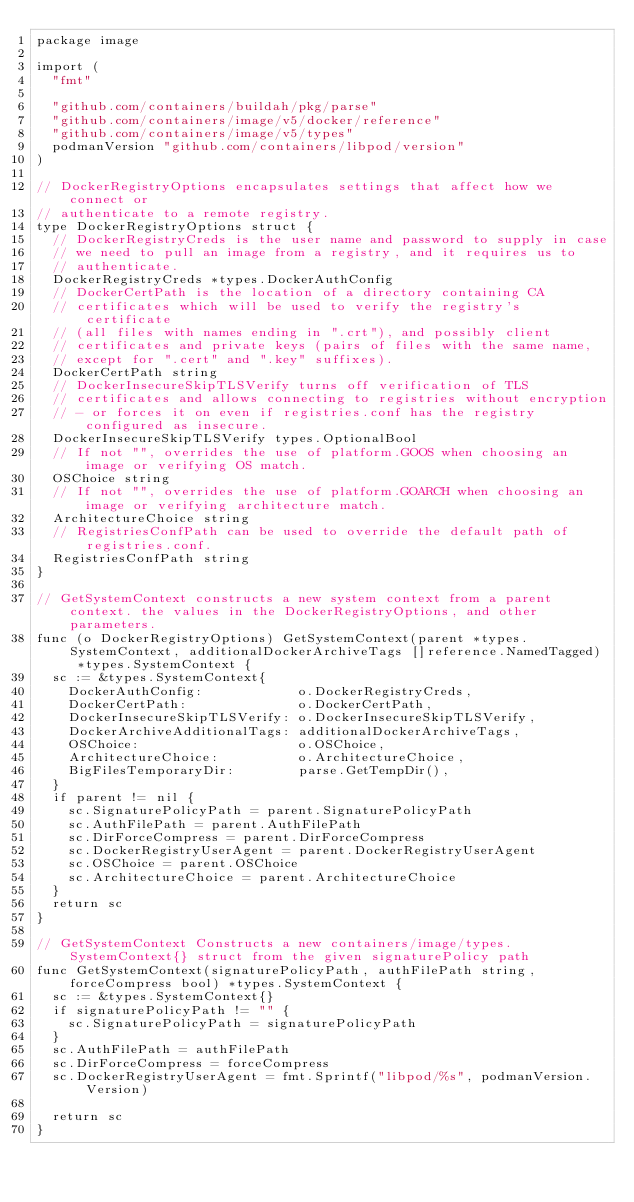Convert code to text. <code><loc_0><loc_0><loc_500><loc_500><_Go_>package image

import (
	"fmt"

	"github.com/containers/buildah/pkg/parse"
	"github.com/containers/image/v5/docker/reference"
	"github.com/containers/image/v5/types"
	podmanVersion "github.com/containers/libpod/version"
)

// DockerRegistryOptions encapsulates settings that affect how we connect or
// authenticate to a remote registry.
type DockerRegistryOptions struct {
	// DockerRegistryCreds is the user name and password to supply in case
	// we need to pull an image from a registry, and it requires us to
	// authenticate.
	DockerRegistryCreds *types.DockerAuthConfig
	// DockerCertPath is the location of a directory containing CA
	// certificates which will be used to verify the registry's certificate
	// (all files with names ending in ".crt"), and possibly client
	// certificates and private keys (pairs of files with the same name,
	// except for ".cert" and ".key" suffixes).
	DockerCertPath string
	// DockerInsecureSkipTLSVerify turns off verification of TLS
	// certificates and allows connecting to registries without encryption
	// - or forces it on even if registries.conf has the registry configured as insecure.
	DockerInsecureSkipTLSVerify types.OptionalBool
	// If not "", overrides the use of platform.GOOS when choosing an image or verifying OS match.
	OSChoice string
	// If not "", overrides the use of platform.GOARCH when choosing an image or verifying architecture match.
	ArchitectureChoice string
	// RegistriesConfPath can be used to override the default path of registries.conf.
	RegistriesConfPath string
}

// GetSystemContext constructs a new system context from a parent context. the values in the DockerRegistryOptions, and other parameters.
func (o DockerRegistryOptions) GetSystemContext(parent *types.SystemContext, additionalDockerArchiveTags []reference.NamedTagged) *types.SystemContext {
	sc := &types.SystemContext{
		DockerAuthConfig:            o.DockerRegistryCreds,
		DockerCertPath:              o.DockerCertPath,
		DockerInsecureSkipTLSVerify: o.DockerInsecureSkipTLSVerify,
		DockerArchiveAdditionalTags: additionalDockerArchiveTags,
		OSChoice:                    o.OSChoice,
		ArchitectureChoice:          o.ArchitectureChoice,
		BigFilesTemporaryDir:        parse.GetTempDir(),
	}
	if parent != nil {
		sc.SignaturePolicyPath = parent.SignaturePolicyPath
		sc.AuthFilePath = parent.AuthFilePath
		sc.DirForceCompress = parent.DirForceCompress
		sc.DockerRegistryUserAgent = parent.DockerRegistryUserAgent
		sc.OSChoice = parent.OSChoice
		sc.ArchitectureChoice = parent.ArchitectureChoice
	}
	return sc
}

// GetSystemContext Constructs a new containers/image/types.SystemContext{} struct from the given signaturePolicy path
func GetSystemContext(signaturePolicyPath, authFilePath string, forceCompress bool) *types.SystemContext {
	sc := &types.SystemContext{}
	if signaturePolicyPath != "" {
		sc.SignaturePolicyPath = signaturePolicyPath
	}
	sc.AuthFilePath = authFilePath
	sc.DirForceCompress = forceCompress
	sc.DockerRegistryUserAgent = fmt.Sprintf("libpod/%s", podmanVersion.Version)

	return sc
}
</code> 